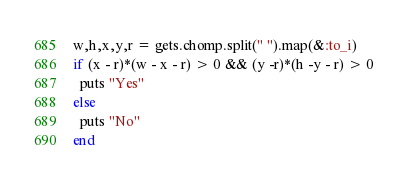Convert code to text. <code><loc_0><loc_0><loc_500><loc_500><_Ruby_>w,h,x,y,r = gets.chomp.split(" ").map(&:to_i)
if (x - r)*(w - x - r) > 0 && (y -r)*(h -y - r) > 0
  puts "Yes"
else
  puts "No"
end</code> 